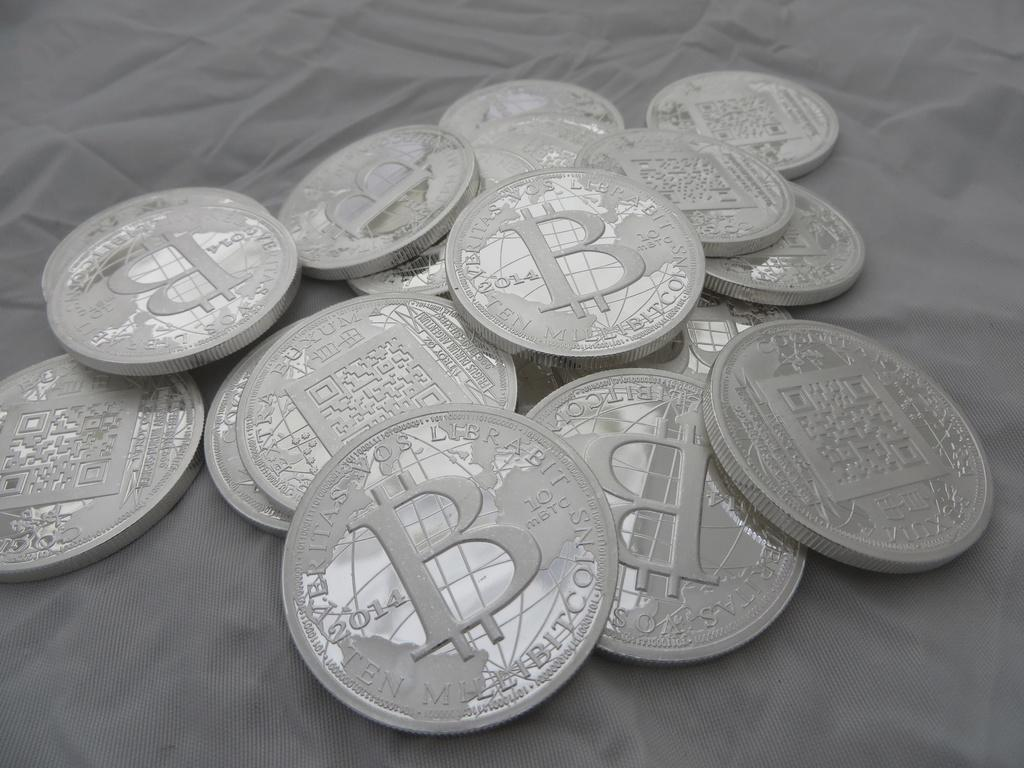<image>
Share a concise interpretation of the image provided. A pile of ten Millibitcoins sits on a sheet. 